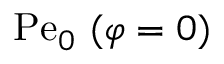<formula> <loc_0><loc_0><loc_500><loc_500>P e _ { 0 } \ ( \varphi = 0 )</formula> 